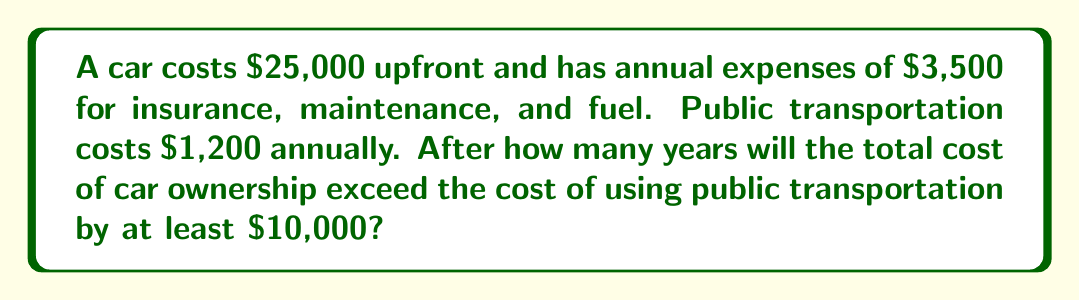Give your solution to this math problem. Let's approach this step-by-step:

1) First, let's define our variables:
   $x$ = number of years
   $C$ = total cost of car ownership after $x$ years
   $P$ = total cost of public transportation after $x$ years

2) We can express these costs as functions of $x$:
   $C = 25000 + 3500x$
   $P = 1200x$

3) We want to find when the difference between these costs is at least $10,000:
   $C - P \geq 10000$

4) Substituting our expressions:
   $(25000 + 3500x) - 1200x \geq 10000$

5) Simplify:
   $25000 + 2300x \geq 10000$

6) Subtract 25000 from both sides:
   $2300x \geq -15000$

7) Divide both sides by 2300:
   $x \geq -\frac{15000}{2300} \approx -6.52$

8) Since we can't have negative years, and we need the smallest whole number of years that satisfies the inequality, we round up to the nearest whole number:

   $x = 7$ years

9) Let's verify:
   At 7 years:
   $C = 25000 + 3500(7) = 49500$
   $P = 1200(7) = 8400$
   $C - P = 49500 - 8400 = 41100$
   $41100 > 10000$, so this satisfies our condition.
Answer: 7 years 